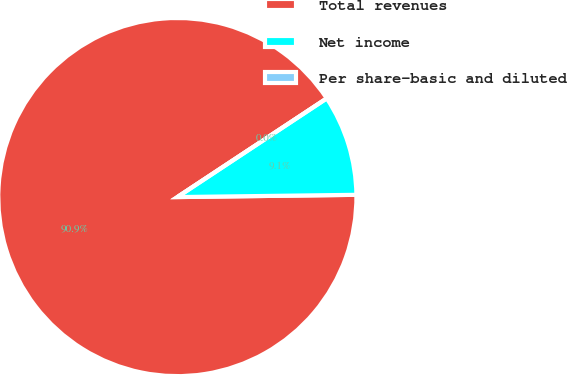Convert chart to OTSL. <chart><loc_0><loc_0><loc_500><loc_500><pie_chart><fcel>Total revenues<fcel>Net income<fcel>Per share-basic and diluted<nl><fcel>90.91%<fcel>9.09%<fcel>0.0%<nl></chart> 